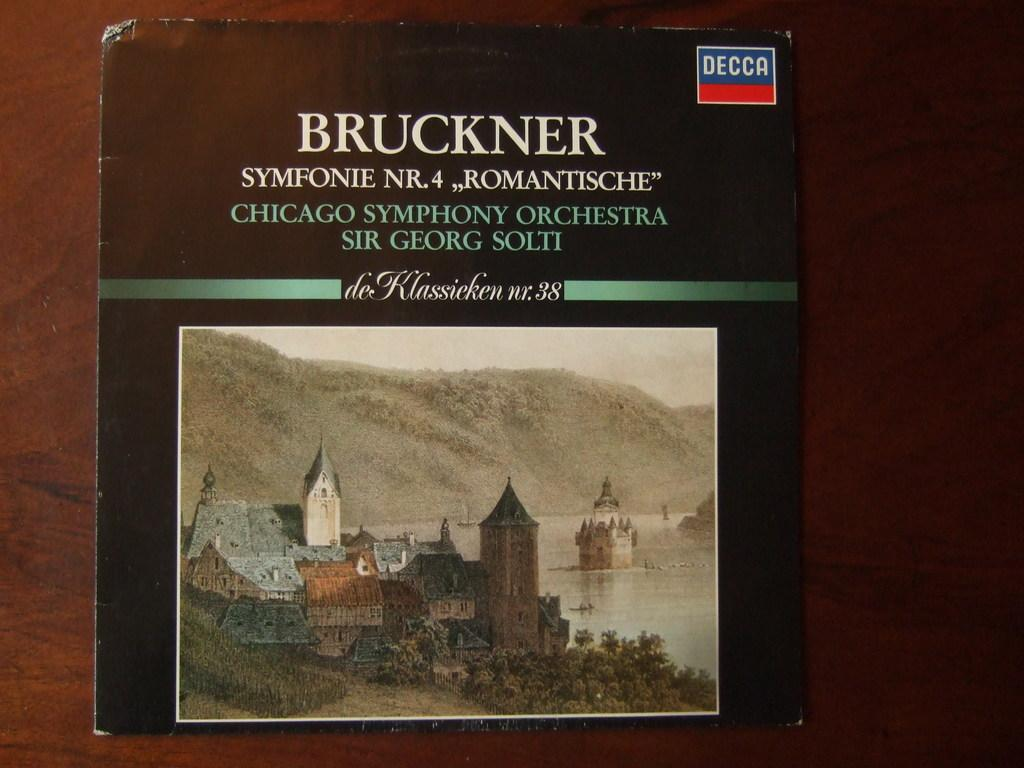Provide a one-sentence caption for the provided image. A LP record of Bruckner Symfonie Nr 4 played by the Chicago Symphony Orchestra laying on top of a wood table top. 